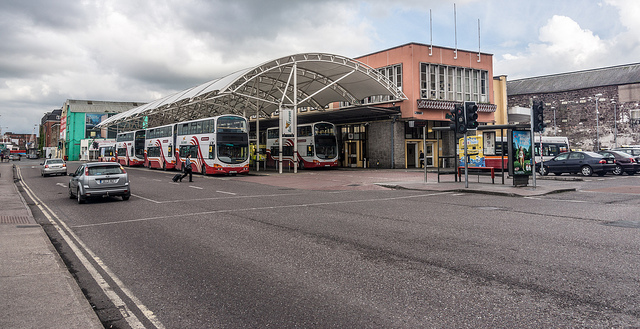Could you describe the architecture of the bus station shown in the image? Certainly! The bus station in the image features a distinctive semi-circular canopy, possibly made of steel and glass, providing shelter. The structure combines functional and modern design elements, typical of mid-20th century public transit infrastructures, which aims to offer both aesthetic appeal and practicality in busy urban settings. 